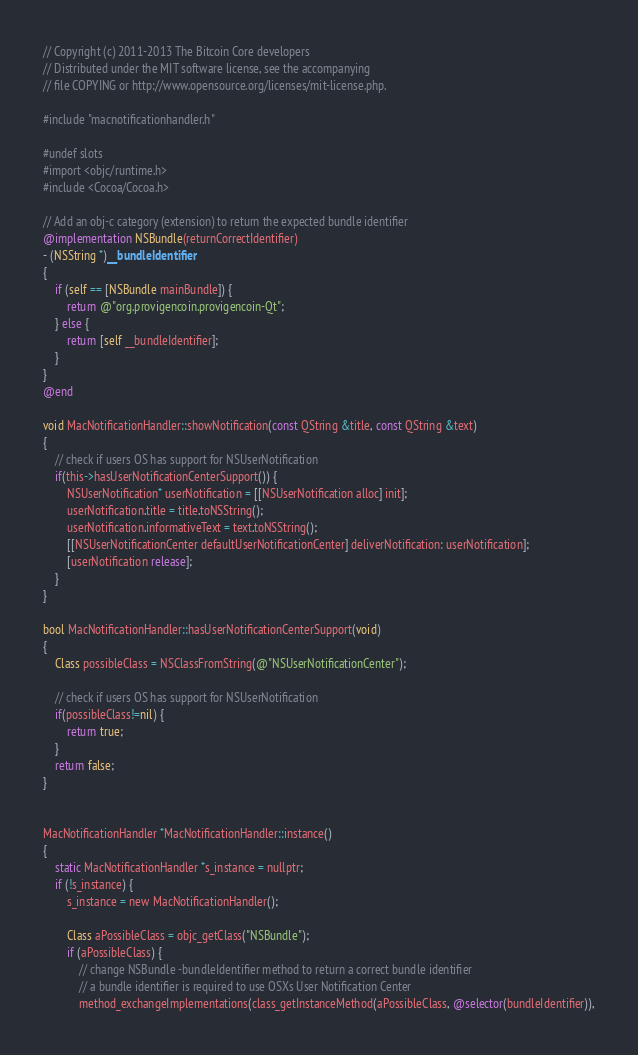<code> <loc_0><loc_0><loc_500><loc_500><_ObjectiveC_>// Copyright (c) 2011-2013 The Bitcoin Core developers
// Distributed under the MIT software license, see the accompanying
// file COPYING or http://www.opensource.org/licenses/mit-license.php.

#include "macnotificationhandler.h"

#undef slots
#import <objc/runtime.h>
#include <Cocoa/Cocoa.h>

// Add an obj-c category (extension) to return the expected bundle identifier
@implementation NSBundle(returnCorrectIdentifier)
- (NSString *)__bundleIdentifier
{
    if (self == [NSBundle mainBundle]) {
        return @"org.provigencoin.provigencoin-Qt";
    } else {
        return [self __bundleIdentifier];
    }
}
@end

void MacNotificationHandler::showNotification(const QString &title, const QString &text)
{
    // check if users OS has support for NSUserNotification
    if(this->hasUserNotificationCenterSupport()) {
        NSUserNotification* userNotification = [[NSUserNotification alloc] init];
        userNotification.title = title.toNSString();
        userNotification.informativeText = text.toNSString();
        [[NSUserNotificationCenter defaultUserNotificationCenter] deliverNotification: userNotification];
        [userNotification release];
    }
}

bool MacNotificationHandler::hasUserNotificationCenterSupport(void)
{
    Class possibleClass = NSClassFromString(@"NSUserNotificationCenter");

    // check if users OS has support for NSUserNotification
    if(possibleClass!=nil) {
        return true;
    }
    return false;
}


MacNotificationHandler *MacNotificationHandler::instance()
{
    static MacNotificationHandler *s_instance = nullptr;
    if (!s_instance) {
        s_instance = new MacNotificationHandler();

        Class aPossibleClass = objc_getClass("NSBundle");
        if (aPossibleClass) {
            // change NSBundle -bundleIdentifier method to return a correct bundle identifier
            // a bundle identifier is required to use OSXs User Notification Center
            method_exchangeImplementations(class_getInstanceMethod(aPossibleClass, @selector(bundleIdentifier)),</code> 